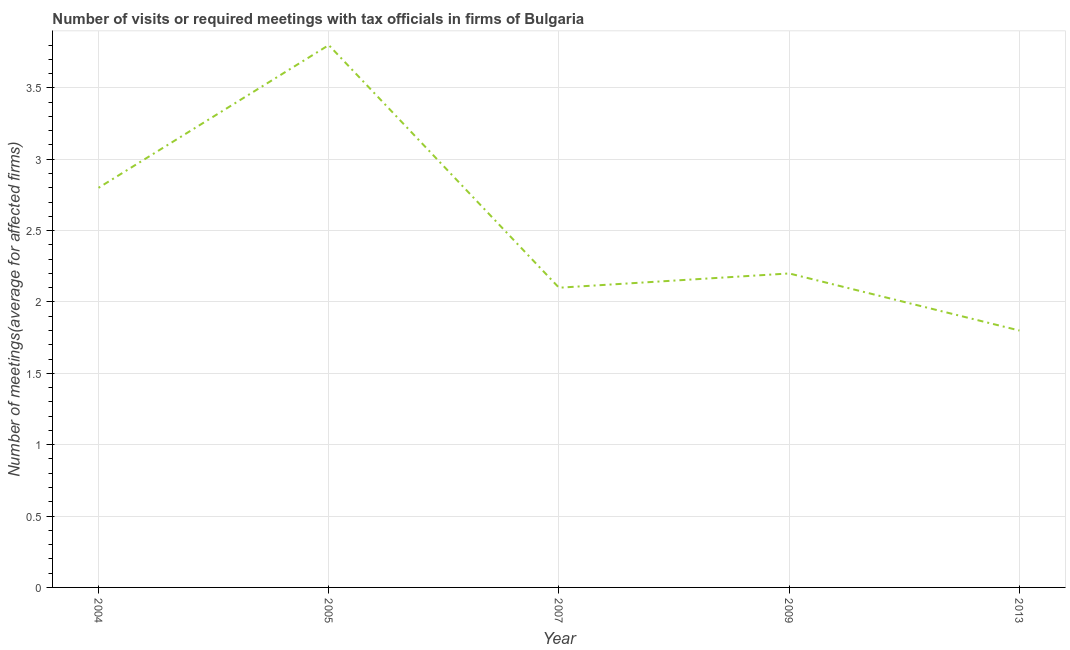What is the number of required meetings with tax officials in 2009?
Provide a short and direct response. 2.2. Across all years, what is the maximum number of required meetings with tax officials?
Your answer should be compact. 3.8. What is the sum of the number of required meetings with tax officials?
Make the answer very short. 12.7. What is the difference between the number of required meetings with tax officials in 2004 and 2013?
Give a very brief answer. 1. What is the average number of required meetings with tax officials per year?
Offer a very short reply. 2.54. What is the ratio of the number of required meetings with tax officials in 2005 to that in 2013?
Your answer should be very brief. 2.11. Is the number of required meetings with tax officials in 2004 less than that in 2007?
Make the answer very short. No. Is the difference between the number of required meetings with tax officials in 2005 and 2009 greater than the difference between any two years?
Your answer should be compact. No. What is the difference between the highest and the lowest number of required meetings with tax officials?
Offer a very short reply. 2. In how many years, is the number of required meetings with tax officials greater than the average number of required meetings with tax officials taken over all years?
Offer a very short reply. 2. Does the number of required meetings with tax officials monotonically increase over the years?
Give a very brief answer. No. How many lines are there?
Provide a succinct answer. 1. What is the difference between two consecutive major ticks on the Y-axis?
Provide a short and direct response. 0.5. Does the graph contain grids?
Provide a short and direct response. Yes. What is the title of the graph?
Your response must be concise. Number of visits or required meetings with tax officials in firms of Bulgaria. What is the label or title of the X-axis?
Keep it short and to the point. Year. What is the label or title of the Y-axis?
Ensure brevity in your answer.  Number of meetings(average for affected firms). What is the Number of meetings(average for affected firms) in 2004?
Give a very brief answer. 2.8. What is the Number of meetings(average for affected firms) in 2005?
Offer a terse response. 3.8. What is the Number of meetings(average for affected firms) in 2009?
Offer a very short reply. 2.2. What is the difference between the Number of meetings(average for affected firms) in 2004 and 2013?
Offer a very short reply. 1. What is the difference between the Number of meetings(average for affected firms) in 2005 and 2007?
Give a very brief answer. 1.7. What is the difference between the Number of meetings(average for affected firms) in 2005 and 2013?
Your response must be concise. 2. What is the difference between the Number of meetings(average for affected firms) in 2007 and 2013?
Offer a terse response. 0.3. What is the ratio of the Number of meetings(average for affected firms) in 2004 to that in 2005?
Provide a short and direct response. 0.74. What is the ratio of the Number of meetings(average for affected firms) in 2004 to that in 2007?
Make the answer very short. 1.33. What is the ratio of the Number of meetings(average for affected firms) in 2004 to that in 2009?
Make the answer very short. 1.27. What is the ratio of the Number of meetings(average for affected firms) in 2004 to that in 2013?
Provide a short and direct response. 1.56. What is the ratio of the Number of meetings(average for affected firms) in 2005 to that in 2007?
Offer a very short reply. 1.81. What is the ratio of the Number of meetings(average for affected firms) in 2005 to that in 2009?
Keep it short and to the point. 1.73. What is the ratio of the Number of meetings(average for affected firms) in 2005 to that in 2013?
Your answer should be compact. 2.11. What is the ratio of the Number of meetings(average for affected firms) in 2007 to that in 2009?
Your answer should be very brief. 0.95. What is the ratio of the Number of meetings(average for affected firms) in 2007 to that in 2013?
Ensure brevity in your answer.  1.17. What is the ratio of the Number of meetings(average for affected firms) in 2009 to that in 2013?
Ensure brevity in your answer.  1.22. 